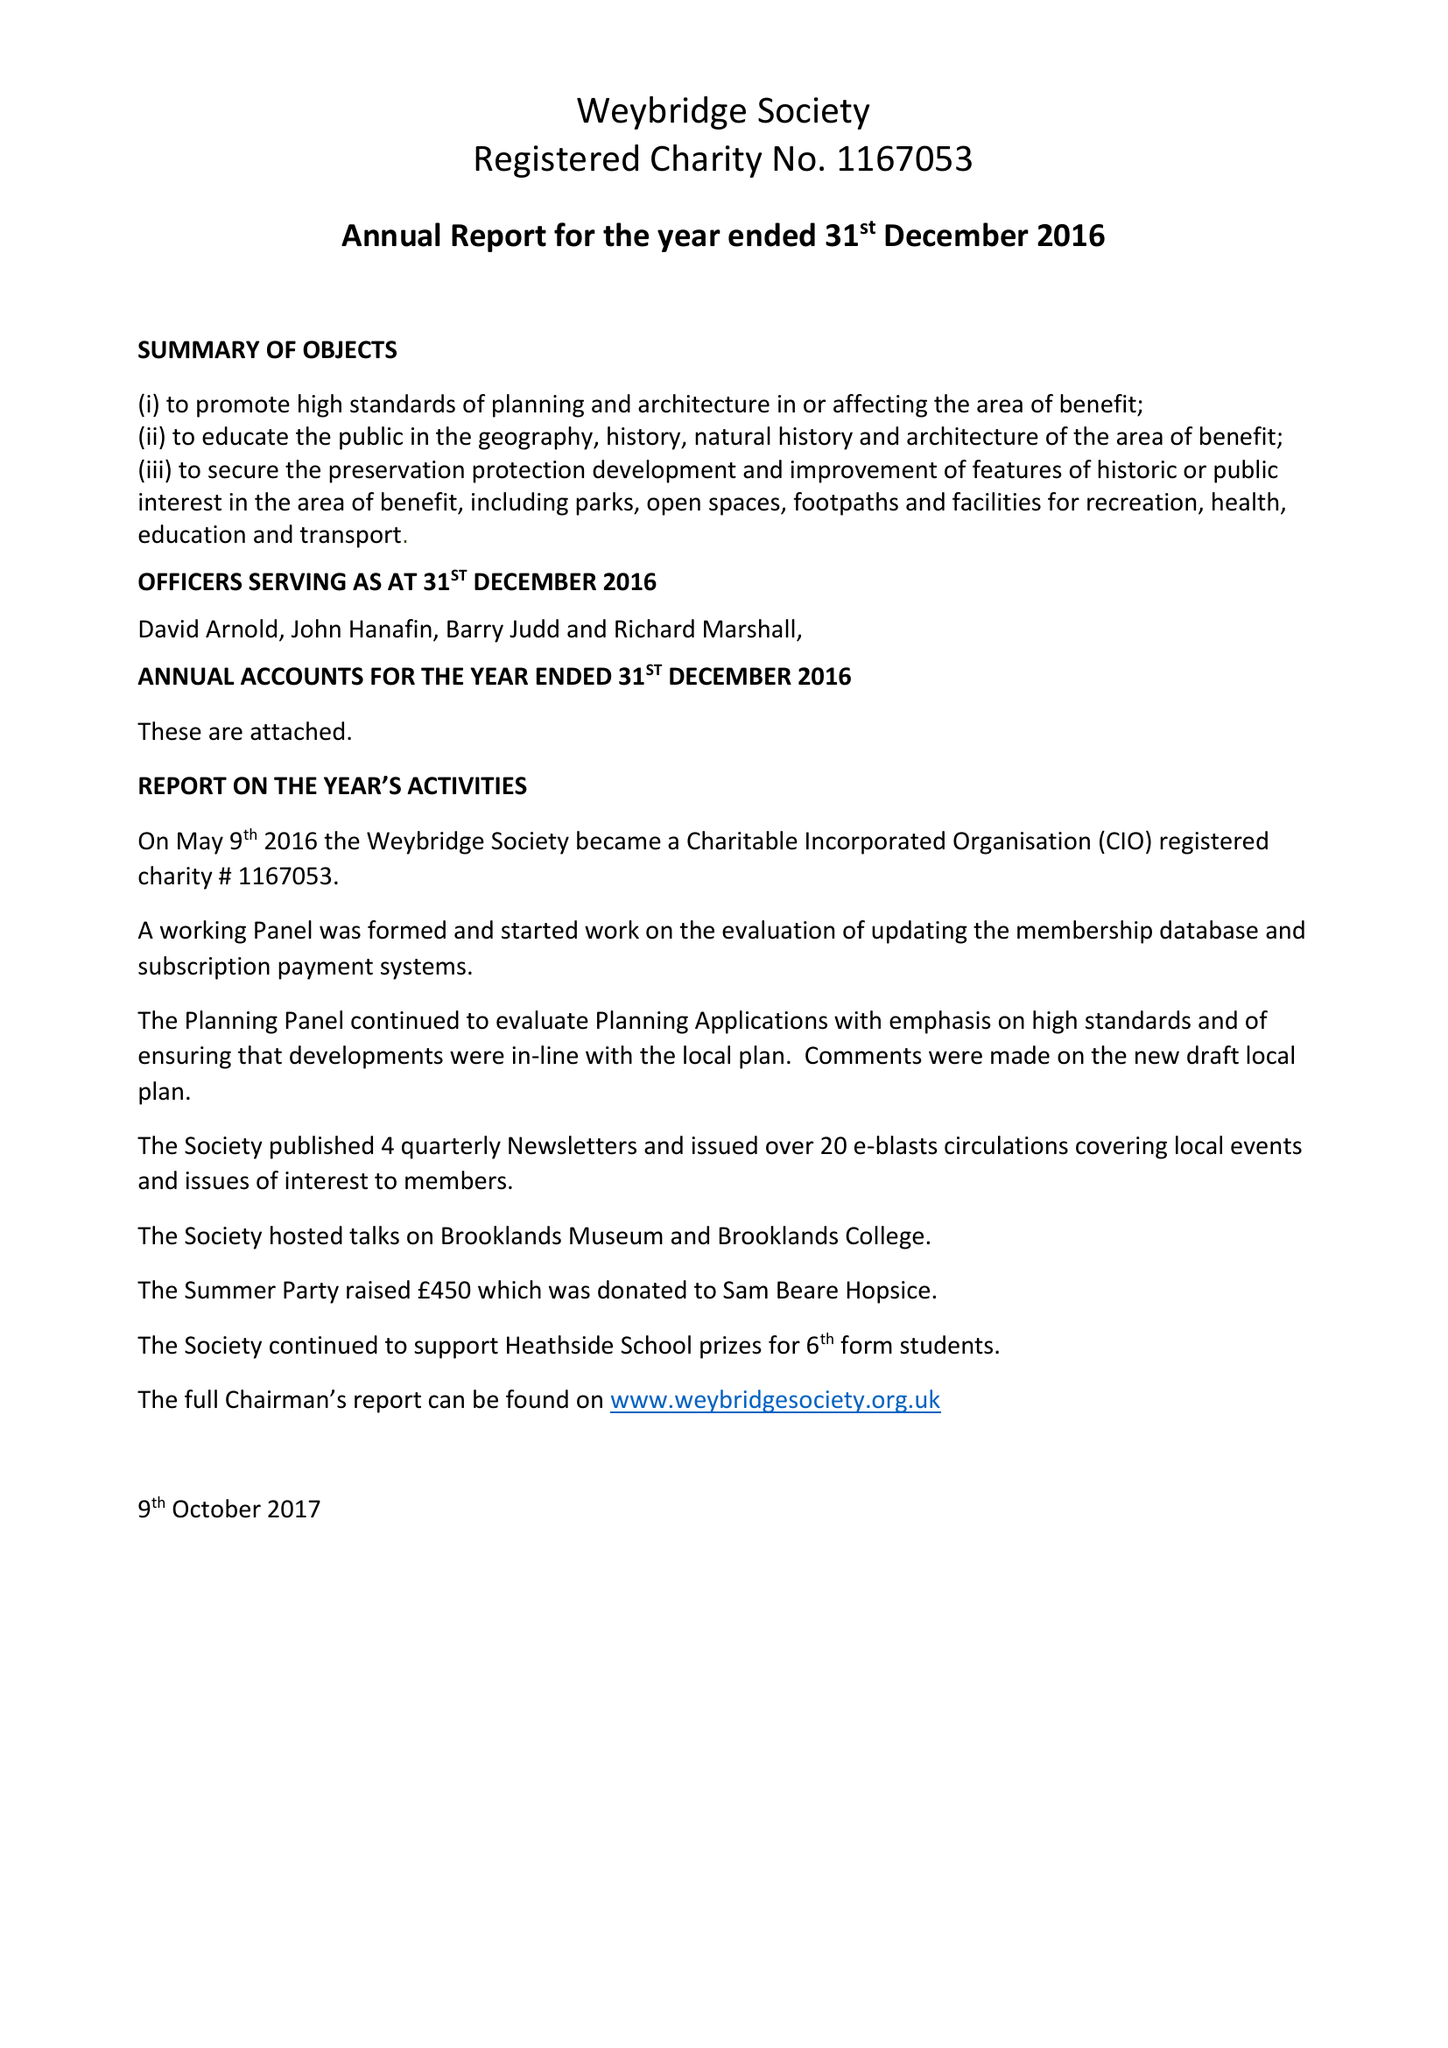What is the value for the address__street_line?
Answer the question using a single word or phrase. None 